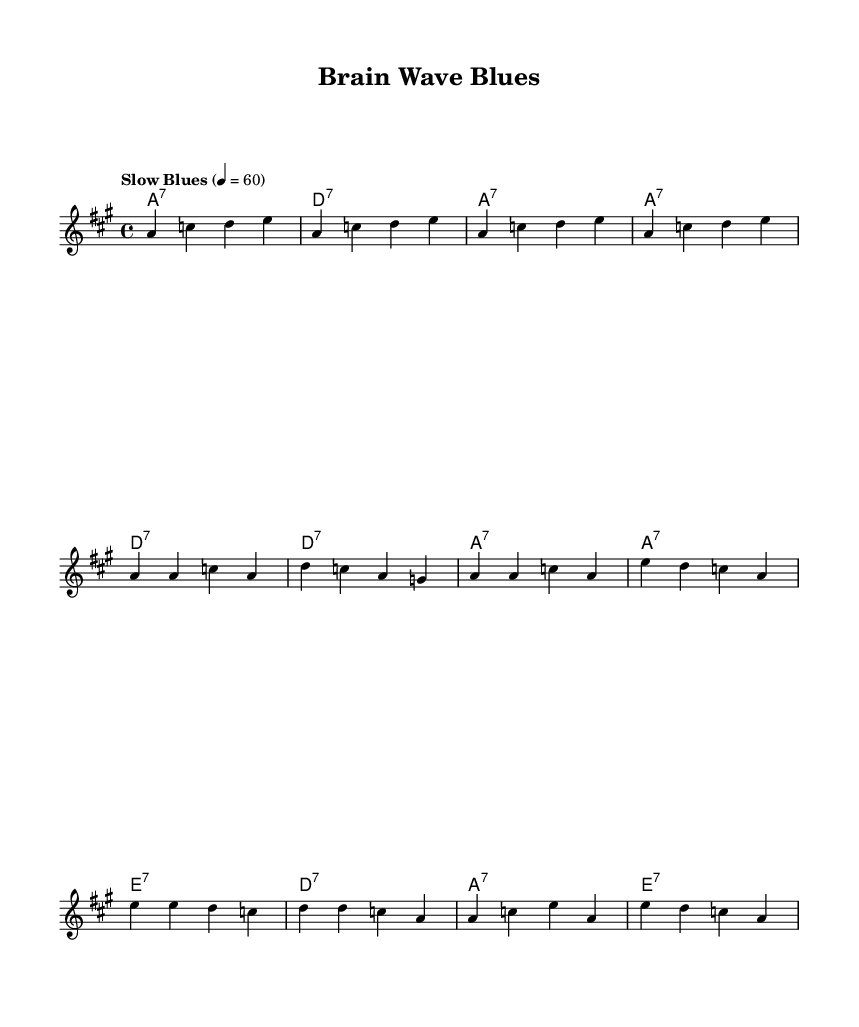What is the key signature of this music? The key signature is A major, which has three sharps (F#, C#, and G#). You can identify the key signature near the beginning of the staff, just after the clef sign.
Answer: A major What is the time signature of this piece? The time signature is 4/4, indicated at the beginning of the music. It shows that there are four beats in each measure and a quarter note receives one beat.
Answer: 4/4 What is the tempo marking for this piece? The tempo marking is "Slow Blues," which indicates the style and pace of the music. It can be found near the start of the score, alongside the numerical tempo marking.
Answer: Slow Blues How many measures are in the verse section? The verse section contains four measures. You can count the measures by examining the bar lines. The verse repeats similar phrasing and structure.
Answer: 4 What chord follows the first chord in the melody? The first chord in the harmony is A seventh, followed by a D seventh chord. This can be deduced by looking at the chord notations written above the melody notes.
Answer: D seventh What is the emotional theme expressed in the lyrics? The emotional theme revolves around neurological conditions, particularly as expressed through the lyrics discussing "brain wave blues." This theme is indicative of the blues genre, focusing on personal struggles and feelings.
Answer: Neurological conditions 